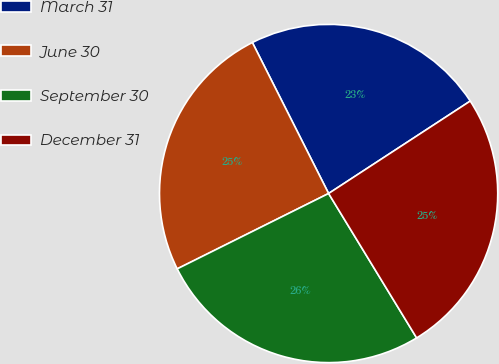Convert chart. <chart><loc_0><loc_0><loc_500><loc_500><pie_chart><fcel>March 31<fcel>June 30<fcel>September 30<fcel>December 31<nl><fcel>23.24%<fcel>24.91%<fcel>26.36%<fcel>25.49%<nl></chart> 